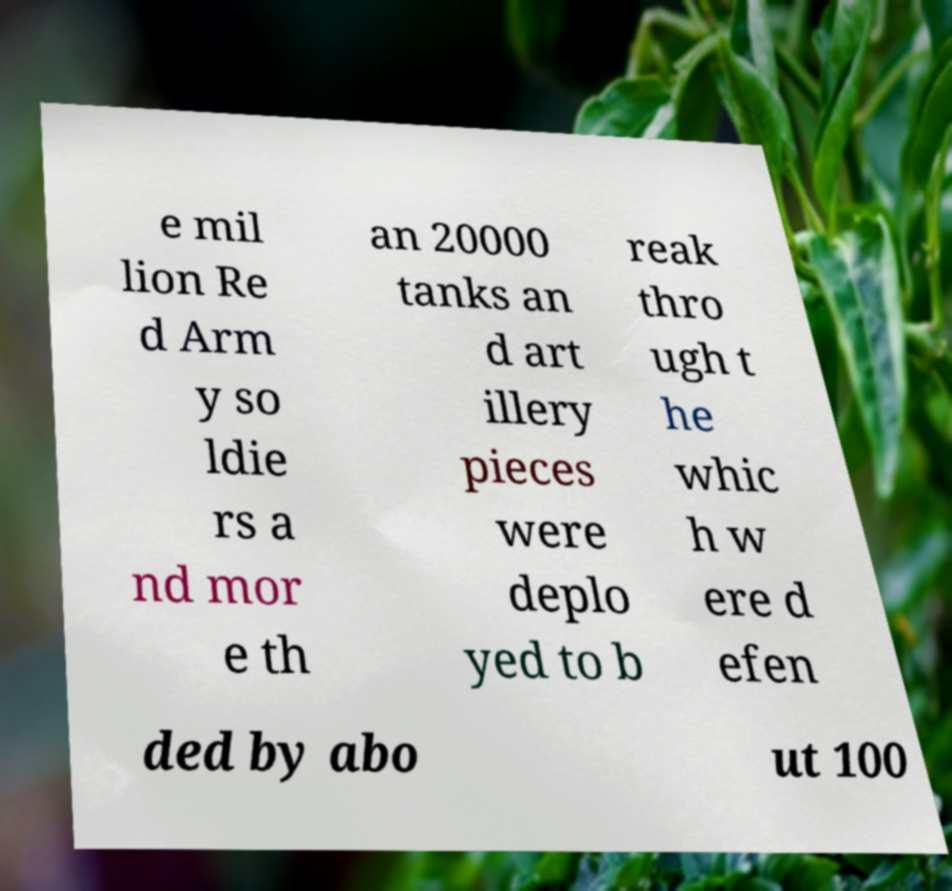I need the written content from this picture converted into text. Can you do that? e mil lion Re d Arm y so ldie rs a nd mor e th an 20000 tanks an d art illery pieces were deplo yed to b reak thro ugh t he whic h w ere d efen ded by abo ut 100 